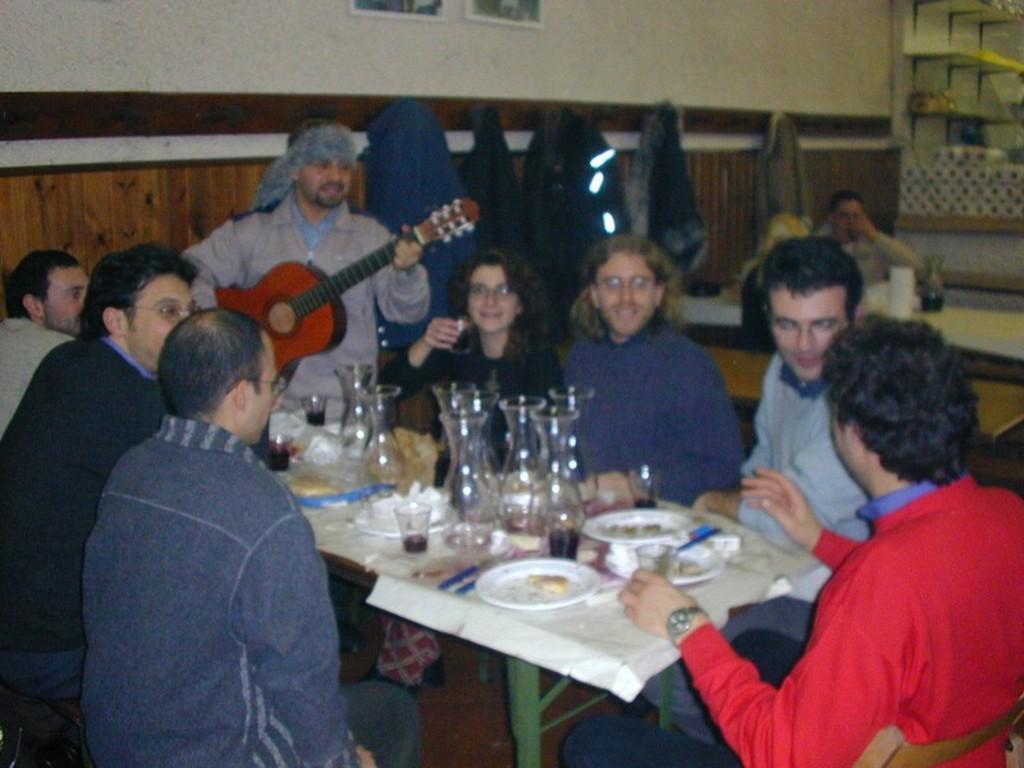How would you summarize this image in a sentence or two? In this picture we can see some persons sitting on the chairs around the table. On the table there is a plate, glass and tissues. Here we can see a person standing and playing a guitar. And on the background we can see lights, and there is a wall. This is the frame. Here we can see one more person sitting on the chair. 